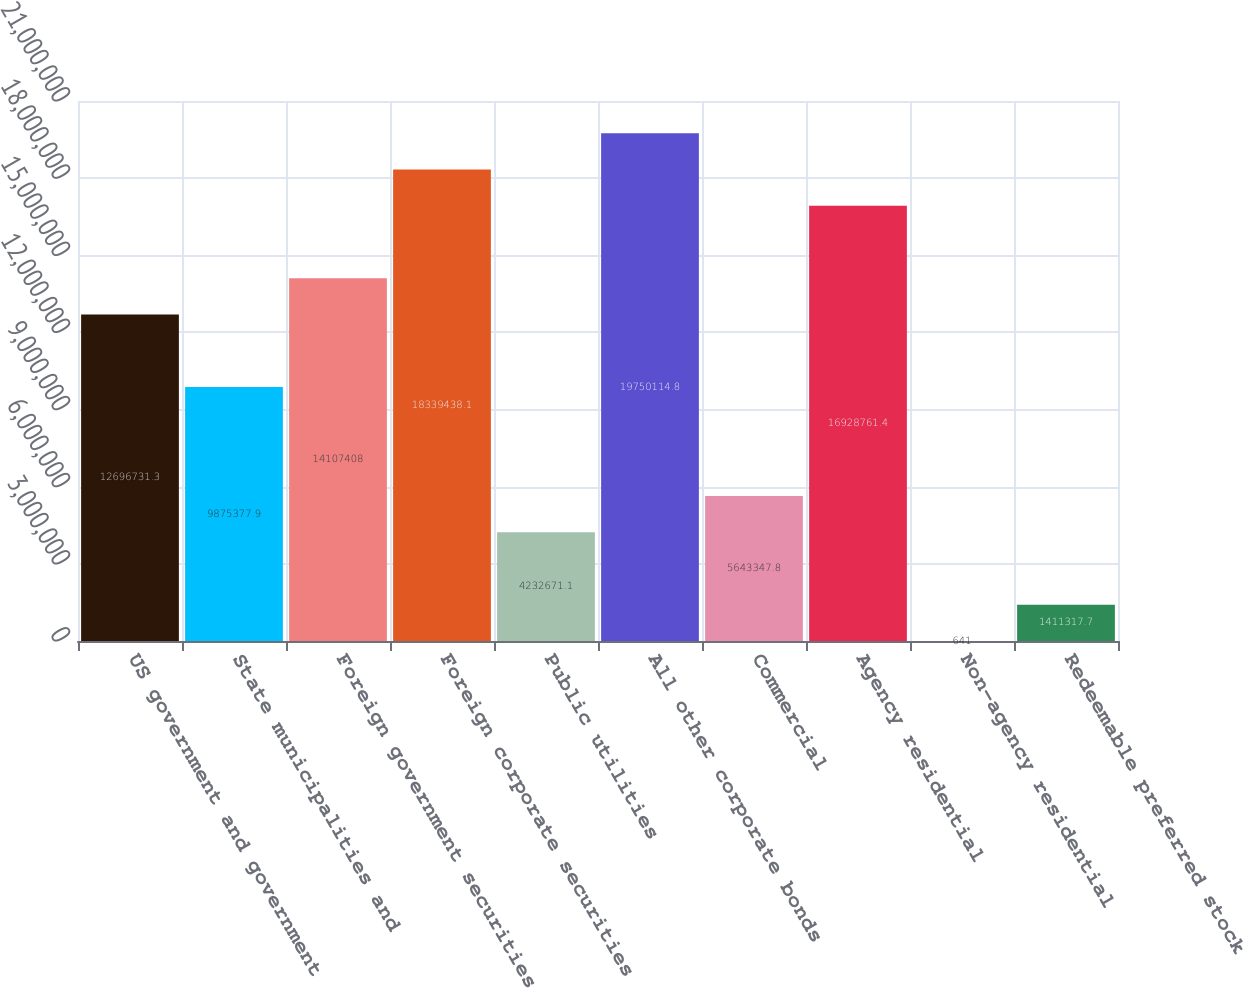Convert chart. <chart><loc_0><loc_0><loc_500><loc_500><bar_chart><fcel>US government and government<fcel>State municipalities and<fcel>Foreign government securities<fcel>Foreign corporate securities<fcel>Public utilities<fcel>All other corporate bonds<fcel>Commercial<fcel>Agency residential<fcel>Non-agency residential<fcel>Redeemable preferred stock<nl><fcel>1.26967e+07<fcel>9.87538e+06<fcel>1.41074e+07<fcel>1.83394e+07<fcel>4.23267e+06<fcel>1.97501e+07<fcel>5.64335e+06<fcel>1.69288e+07<fcel>641<fcel>1.41132e+06<nl></chart> 